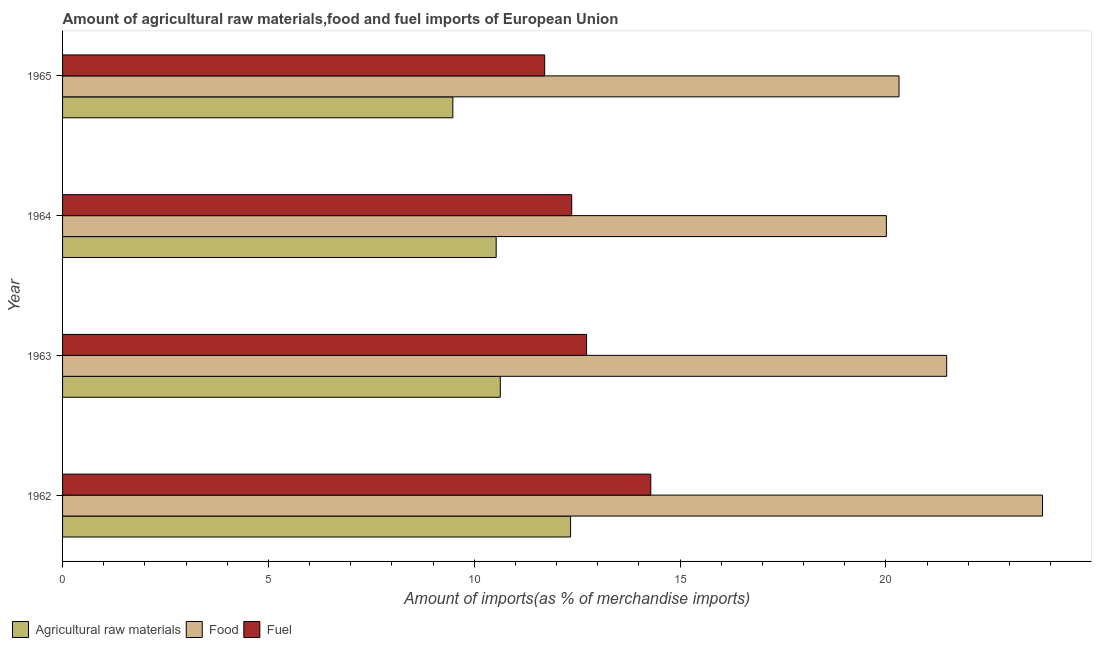Are the number of bars per tick equal to the number of legend labels?
Offer a terse response. Yes. What is the label of the 2nd group of bars from the top?
Your response must be concise. 1964. What is the percentage of raw materials imports in 1964?
Offer a very short reply. 10.53. Across all years, what is the maximum percentage of raw materials imports?
Provide a succinct answer. 12.34. Across all years, what is the minimum percentage of fuel imports?
Offer a terse response. 11.71. In which year was the percentage of fuel imports maximum?
Your answer should be very brief. 1962. In which year was the percentage of food imports minimum?
Your response must be concise. 1964. What is the total percentage of fuel imports in the graph?
Your answer should be very brief. 51.1. What is the difference between the percentage of raw materials imports in 1964 and that in 1965?
Your response must be concise. 1.05. What is the difference between the percentage of fuel imports in 1964 and the percentage of food imports in 1965?
Give a very brief answer. -7.95. What is the average percentage of food imports per year?
Make the answer very short. 21.4. In the year 1965, what is the difference between the percentage of food imports and percentage of fuel imports?
Ensure brevity in your answer.  8.61. What is the ratio of the percentage of food imports in 1963 to that in 1965?
Make the answer very short. 1.06. Is the percentage of fuel imports in 1962 less than that in 1965?
Offer a terse response. No. Is the difference between the percentage of fuel imports in 1962 and 1963 greater than the difference between the percentage of raw materials imports in 1962 and 1963?
Offer a very short reply. No. What is the difference between the highest and the second highest percentage of food imports?
Keep it short and to the point. 2.33. What is the difference between the highest and the lowest percentage of food imports?
Ensure brevity in your answer.  3.79. Is the sum of the percentage of raw materials imports in 1962 and 1965 greater than the maximum percentage of fuel imports across all years?
Your answer should be very brief. Yes. What does the 1st bar from the top in 1965 represents?
Provide a succinct answer. Fuel. What does the 1st bar from the bottom in 1964 represents?
Make the answer very short. Agricultural raw materials. How many bars are there?
Provide a short and direct response. 12. How many years are there in the graph?
Make the answer very short. 4. Are the values on the major ticks of X-axis written in scientific E-notation?
Your answer should be very brief. No. Does the graph contain any zero values?
Your answer should be compact. No. Does the graph contain grids?
Provide a succinct answer. No. How many legend labels are there?
Make the answer very short. 3. How are the legend labels stacked?
Your response must be concise. Horizontal. What is the title of the graph?
Keep it short and to the point. Amount of agricultural raw materials,food and fuel imports of European Union. Does "Industry" appear as one of the legend labels in the graph?
Give a very brief answer. No. What is the label or title of the X-axis?
Your answer should be compact. Amount of imports(as % of merchandise imports). What is the Amount of imports(as % of merchandise imports) in Agricultural raw materials in 1962?
Your response must be concise. 12.34. What is the Amount of imports(as % of merchandise imports) in Food in 1962?
Your answer should be compact. 23.8. What is the Amount of imports(as % of merchandise imports) of Fuel in 1962?
Make the answer very short. 14.29. What is the Amount of imports(as % of merchandise imports) of Agricultural raw materials in 1963?
Make the answer very short. 10.63. What is the Amount of imports(as % of merchandise imports) in Food in 1963?
Provide a succinct answer. 21.48. What is the Amount of imports(as % of merchandise imports) of Fuel in 1963?
Provide a short and direct response. 12.73. What is the Amount of imports(as % of merchandise imports) in Agricultural raw materials in 1964?
Offer a very short reply. 10.53. What is the Amount of imports(as % of merchandise imports) in Food in 1964?
Ensure brevity in your answer.  20.01. What is the Amount of imports(as % of merchandise imports) in Fuel in 1964?
Provide a succinct answer. 12.37. What is the Amount of imports(as % of merchandise imports) of Agricultural raw materials in 1965?
Keep it short and to the point. 9.48. What is the Amount of imports(as % of merchandise imports) of Food in 1965?
Your answer should be compact. 20.32. What is the Amount of imports(as % of merchandise imports) in Fuel in 1965?
Give a very brief answer. 11.71. Across all years, what is the maximum Amount of imports(as % of merchandise imports) in Agricultural raw materials?
Provide a succinct answer. 12.34. Across all years, what is the maximum Amount of imports(as % of merchandise imports) of Food?
Give a very brief answer. 23.8. Across all years, what is the maximum Amount of imports(as % of merchandise imports) in Fuel?
Your answer should be very brief. 14.29. Across all years, what is the minimum Amount of imports(as % of merchandise imports) in Agricultural raw materials?
Ensure brevity in your answer.  9.48. Across all years, what is the minimum Amount of imports(as % of merchandise imports) of Food?
Keep it short and to the point. 20.01. Across all years, what is the minimum Amount of imports(as % of merchandise imports) of Fuel?
Ensure brevity in your answer.  11.71. What is the total Amount of imports(as % of merchandise imports) of Agricultural raw materials in the graph?
Provide a short and direct response. 42.99. What is the total Amount of imports(as % of merchandise imports) in Food in the graph?
Ensure brevity in your answer.  85.61. What is the total Amount of imports(as % of merchandise imports) in Fuel in the graph?
Make the answer very short. 51.1. What is the difference between the Amount of imports(as % of merchandise imports) in Agricultural raw materials in 1962 and that in 1963?
Keep it short and to the point. 1.71. What is the difference between the Amount of imports(as % of merchandise imports) of Food in 1962 and that in 1963?
Your answer should be very brief. 2.33. What is the difference between the Amount of imports(as % of merchandise imports) of Fuel in 1962 and that in 1963?
Offer a very short reply. 1.56. What is the difference between the Amount of imports(as % of merchandise imports) in Agricultural raw materials in 1962 and that in 1964?
Offer a very short reply. 1.81. What is the difference between the Amount of imports(as % of merchandise imports) of Food in 1962 and that in 1964?
Provide a short and direct response. 3.79. What is the difference between the Amount of imports(as % of merchandise imports) of Fuel in 1962 and that in 1964?
Make the answer very short. 1.92. What is the difference between the Amount of imports(as % of merchandise imports) of Agricultural raw materials in 1962 and that in 1965?
Your answer should be compact. 2.86. What is the difference between the Amount of imports(as % of merchandise imports) of Food in 1962 and that in 1965?
Ensure brevity in your answer.  3.49. What is the difference between the Amount of imports(as % of merchandise imports) in Fuel in 1962 and that in 1965?
Your response must be concise. 2.58. What is the difference between the Amount of imports(as % of merchandise imports) in Agricultural raw materials in 1963 and that in 1964?
Offer a very short reply. 0.1. What is the difference between the Amount of imports(as % of merchandise imports) in Food in 1963 and that in 1964?
Provide a succinct answer. 1.46. What is the difference between the Amount of imports(as % of merchandise imports) in Fuel in 1963 and that in 1964?
Ensure brevity in your answer.  0.36. What is the difference between the Amount of imports(as % of merchandise imports) of Agricultural raw materials in 1963 and that in 1965?
Your response must be concise. 1.15. What is the difference between the Amount of imports(as % of merchandise imports) of Food in 1963 and that in 1965?
Your answer should be very brief. 1.16. What is the difference between the Amount of imports(as % of merchandise imports) in Fuel in 1963 and that in 1965?
Offer a terse response. 1.02. What is the difference between the Amount of imports(as % of merchandise imports) in Agricultural raw materials in 1964 and that in 1965?
Your response must be concise. 1.05. What is the difference between the Amount of imports(as % of merchandise imports) of Food in 1964 and that in 1965?
Your response must be concise. -0.31. What is the difference between the Amount of imports(as % of merchandise imports) in Fuel in 1964 and that in 1965?
Offer a very short reply. 0.66. What is the difference between the Amount of imports(as % of merchandise imports) in Agricultural raw materials in 1962 and the Amount of imports(as % of merchandise imports) in Food in 1963?
Ensure brevity in your answer.  -9.14. What is the difference between the Amount of imports(as % of merchandise imports) in Agricultural raw materials in 1962 and the Amount of imports(as % of merchandise imports) in Fuel in 1963?
Offer a terse response. -0.39. What is the difference between the Amount of imports(as % of merchandise imports) in Food in 1962 and the Amount of imports(as % of merchandise imports) in Fuel in 1963?
Provide a succinct answer. 11.08. What is the difference between the Amount of imports(as % of merchandise imports) in Agricultural raw materials in 1962 and the Amount of imports(as % of merchandise imports) in Food in 1964?
Keep it short and to the point. -7.67. What is the difference between the Amount of imports(as % of merchandise imports) of Agricultural raw materials in 1962 and the Amount of imports(as % of merchandise imports) of Fuel in 1964?
Offer a terse response. -0.03. What is the difference between the Amount of imports(as % of merchandise imports) of Food in 1962 and the Amount of imports(as % of merchandise imports) of Fuel in 1964?
Your response must be concise. 11.44. What is the difference between the Amount of imports(as % of merchandise imports) in Agricultural raw materials in 1962 and the Amount of imports(as % of merchandise imports) in Food in 1965?
Make the answer very short. -7.98. What is the difference between the Amount of imports(as % of merchandise imports) of Agricultural raw materials in 1962 and the Amount of imports(as % of merchandise imports) of Fuel in 1965?
Your answer should be compact. 0.63. What is the difference between the Amount of imports(as % of merchandise imports) in Food in 1962 and the Amount of imports(as % of merchandise imports) in Fuel in 1965?
Your answer should be very brief. 12.09. What is the difference between the Amount of imports(as % of merchandise imports) in Agricultural raw materials in 1963 and the Amount of imports(as % of merchandise imports) in Food in 1964?
Offer a terse response. -9.38. What is the difference between the Amount of imports(as % of merchandise imports) in Agricultural raw materials in 1963 and the Amount of imports(as % of merchandise imports) in Fuel in 1964?
Keep it short and to the point. -1.73. What is the difference between the Amount of imports(as % of merchandise imports) in Food in 1963 and the Amount of imports(as % of merchandise imports) in Fuel in 1964?
Provide a short and direct response. 9.11. What is the difference between the Amount of imports(as % of merchandise imports) of Agricultural raw materials in 1963 and the Amount of imports(as % of merchandise imports) of Food in 1965?
Provide a short and direct response. -9.69. What is the difference between the Amount of imports(as % of merchandise imports) in Agricultural raw materials in 1963 and the Amount of imports(as % of merchandise imports) in Fuel in 1965?
Give a very brief answer. -1.08. What is the difference between the Amount of imports(as % of merchandise imports) of Food in 1963 and the Amount of imports(as % of merchandise imports) of Fuel in 1965?
Provide a succinct answer. 9.77. What is the difference between the Amount of imports(as % of merchandise imports) of Agricultural raw materials in 1964 and the Amount of imports(as % of merchandise imports) of Food in 1965?
Keep it short and to the point. -9.79. What is the difference between the Amount of imports(as % of merchandise imports) in Agricultural raw materials in 1964 and the Amount of imports(as % of merchandise imports) in Fuel in 1965?
Offer a terse response. -1.18. What is the difference between the Amount of imports(as % of merchandise imports) in Food in 1964 and the Amount of imports(as % of merchandise imports) in Fuel in 1965?
Keep it short and to the point. 8.3. What is the average Amount of imports(as % of merchandise imports) in Agricultural raw materials per year?
Your answer should be compact. 10.75. What is the average Amount of imports(as % of merchandise imports) in Food per year?
Ensure brevity in your answer.  21.4. What is the average Amount of imports(as % of merchandise imports) in Fuel per year?
Your answer should be compact. 12.77. In the year 1962, what is the difference between the Amount of imports(as % of merchandise imports) in Agricultural raw materials and Amount of imports(as % of merchandise imports) in Food?
Provide a succinct answer. -11.46. In the year 1962, what is the difference between the Amount of imports(as % of merchandise imports) of Agricultural raw materials and Amount of imports(as % of merchandise imports) of Fuel?
Your answer should be very brief. -1.95. In the year 1962, what is the difference between the Amount of imports(as % of merchandise imports) in Food and Amount of imports(as % of merchandise imports) in Fuel?
Your answer should be compact. 9.52. In the year 1963, what is the difference between the Amount of imports(as % of merchandise imports) in Agricultural raw materials and Amount of imports(as % of merchandise imports) in Food?
Keep it short and to the point. -10.84. In the year 1963, what is the difference between the Amount of imports(as % of merchandise imports) in Agricultural raw materials and Amount of imports(as % of merchandise imports) in Fuel?
Give a very brief answer. -2.1. In the year 1963, what is the difference between the Amount of imports(as % of merchandise imports) in Food and Amount of imports(as % of merchandise imports) in Fuel?
Offer a terse response. 8.75. In the year 1964, what is the difference between the Amount of imports(as % of merchandise imports) of Agricultural raw materials and Amount of imports(as % of merchandise imports) of Food?
Ensure brevity in your answer.  -9.48. In the year 1964, what is the difference between the Amount of imports(as % of merchandise imports) in Agricultural raw materials and Amount of imports(as % of merchandise imports) in Fuel?
Your answer should be very brief. -1.84. In the year 1964, what is the difference between the Amount of imports(as % of merchandise imports) in Food and Amount of imports(as % of merchandise imports) in Fuel?
Keep it short and to the point. 7.64. In the year 1965, what is the difference between the Amount of imports(as % of merchandise imports) of Agricultural raw materials and Amount of imports(as % of merchandise imports) of Food?
Ensure brevity in your answer.  -10.84. In the year 1965, what is the difference between the Amount of imports(as % of merchandise imports) of Agricultural raw materials and Amount of imports(as % of merchandise imports) of Fuel?
Offer a very short reply. -2.23. In the year 1965, what is the difference between the Amount of imports(as % of merchandise imports) of Food and Amount of imports(as % of merchandise imports) of Fuel?
Provide a short and direct response. 8.61. What is the ratio of the Amount of imports(as % of merchandise imports) in Agricultural raw materials in 1962 to that in 1963?
Provide a succinct answer. 1.16. What is the ratio of the Amount of imports(as % of merchandise imports) of Food in 1962 to that in 1963?
Your answer should be very brief. 1.11. What is the ratio of the Amount of imports(as % of merchandise imports) of Fuel in 1962 to that in 1963?
Make the answer very short. 1.12. What is the ratio of the Amount of imports(as % of merchandise imports) of Agricultural raw materials in 1962 to that in 1964?
Provide a short and direct response. 1.17. What is the ratio of the Amount of imports(as % of merchandise imports) in Food in 1962 to that in 1964?
Your answer should be very brief. 1.19. What is the ratio of the Amount of imports(as % of merchandise imports) of Fuel in 1962 to that in 1964?
Give a very brief answer. 1.16. What is the ratio of the Amount of imports(as % of merchandise imports) in Agricultural raw materials in 1962 to that in 1965?
Your answer should be compact. 1.3. What is the ratio of the Amount of imports(as % of merchandise imports) in Food in 1962 to that in 1965?
Offer a very short reply. 1.17. What is the ratio of the Amount of imports(as % of merchandise imports) of Fuel in 1962 to that in 1965?
Ensure brevity in your answer.  1.22. What is the ratio of the Amount of imports(as % of merchandise imports) of Agricultural raw materials in 1963 to that in 1964?
Provide a succinct answer. 1.01. What is the ratio of the Amount of imports(as % of merchandise imports) in Food in 1963 to that in 1964?
Provide a succinct answer. 1.07. What is the ratio of the Amount of imports(as % of merchandise imports) of Fuel in 1963 to that in 1964?
Offer a terse response. 1.03. What is the ratio of the Amount of imports(as % of merchandise imports) in Agricultural raw materials in 1963 to that in 1965?
Offer a terse response. 1.12. What is the ratio of the Amount of imports(as % of merchandise imports) in Food in 1963 to that in 1965?
Your answer should be very brief. 1.06. What is the ratio of the Amount of imports(as % of merchandise imports) in Fuel in 1963 to that in 1965?
Ensure brevity in your answer.  1.09. What is the ratio of the Amount of imports(as % of merchandise imports) of Agricultural raw materials in 1964 to that in 1965?
Your answer should be compact. 1.11. What is the ratio of the Amount of imports(as % of merchandise imports) of Food in 1964 to that in 1965?
Offer a very short reply. 0.98. What is the ratio of the Amount of imports(as % of merchandise imports) of Fuel in 1964 to that in 1965?
Your answer should be compact. 1.06. What is the difference between the highest and the second highest Amount of imports(as % of merchandise imports) of Agricultural raw materials?
Ensure brevity in your answer.  1.71. What is the difference between the highest and the second highest Amount of imports(as % of merchandise imports) of Food?
Provide a short and direct response. 2.33. What is the difference between the highest and the second highest Amount of imports(as % of merchandise imports) of Fuel?
Keep it short and to the point. 1.56. What is the difference between the highest and the lowest Amount of imports(as % of merchandise imports) of Agricultural raw materials?
Your response must be concise. 2.86. What is the difference between the highest and the lowest Amount of imports(as % of merchandise imports) in Food?
Keep it short and to the point. 3.79. What is the difference between the highest and the lowest Amount of imports(as % of merchandise imports) in Fuel?
Make the answer very short. 2.58. 